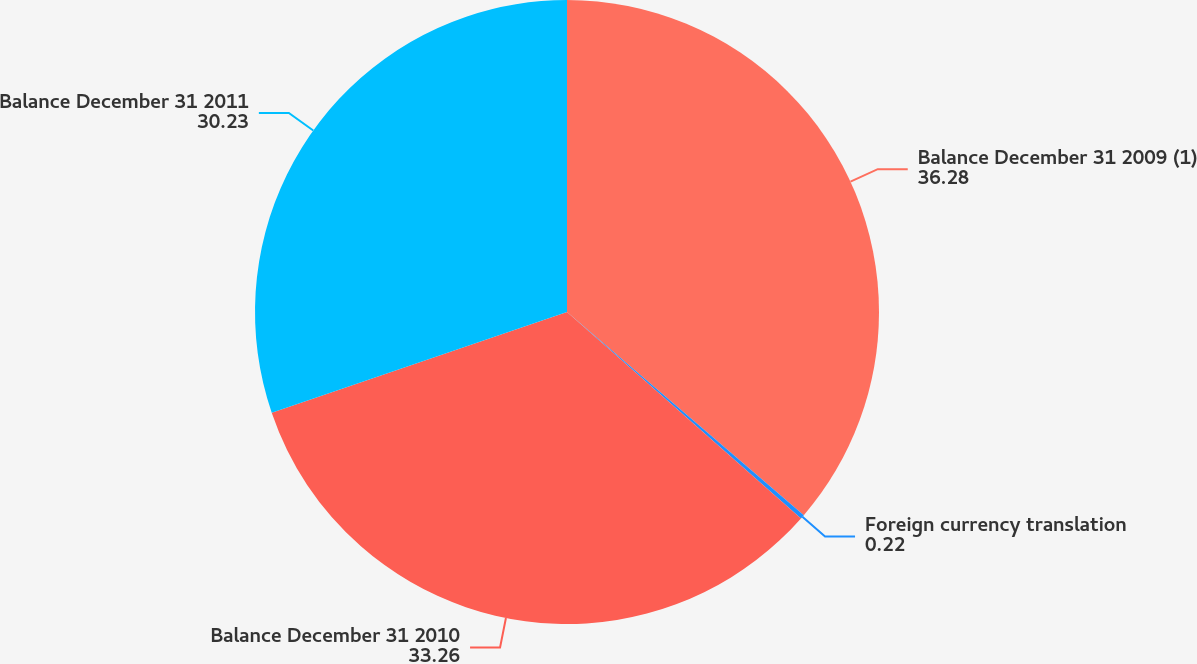<chart> <loc_0><loc_0><loc_500><loc_500><pie_chart><fcel>Balance December 31 2009 (1)<fcel>Foreign currency translation<fcel>Balance December 31 2010<fcel>Balance December 31 2011<nl><fcel>36.28%<fcel>0.22%<fcel>33.26%<fcel>30.23%<nl></chart> 